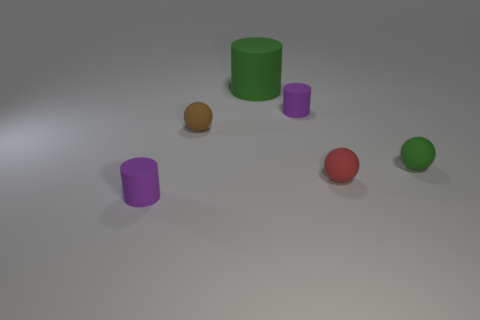How many objects are in the image, and can you describe their colors? There are five objects in the image. Starting from the left, there is a purple cylinder, a red sphere, a green cylinder, a brown sphere, and a small purple cylinder. 